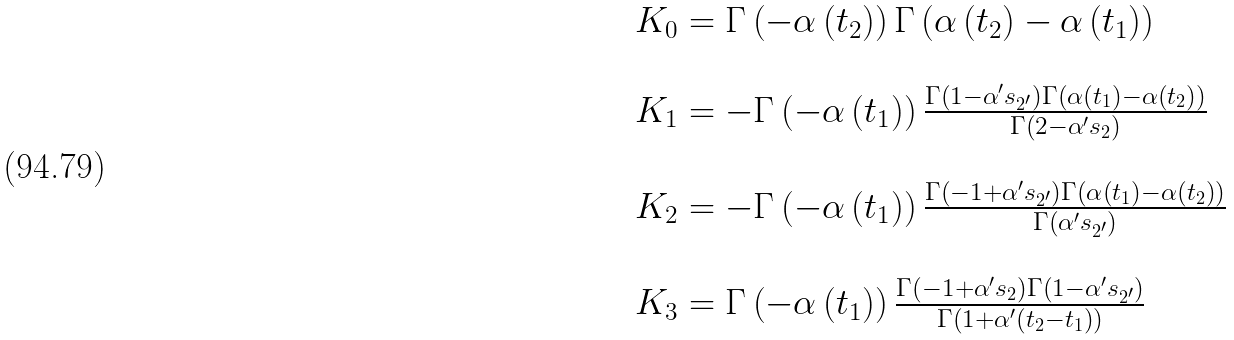<formula> <loc_0><loc_0><loc_500><loc_500>\begin{array} { l } K _ { 0 } = \Gamma \left ( - \alpha \left ( t _ { 2 } \right ) \right ) \Gamma \left ( \alpha \left ( t _ { 2 } \right ) - \alpha \left ( t _ { 1 } \right ) \right ) \\ \\ K _ { 1 } = - \Gamma \left ( - \alpha \left ( t _ { 1 } \right ) \right ) \frac { \Gamma \left ( 1 - \alpha ^ { \prime } s _ { 2 ^ { \prime } } \right ) \Gamma \left ( \alpha \left ( t _ { 1 } \right ) - \alpha \left ( t _ { 2 } \right ) \right ) } { \Gamma \left ( 2 - \alpha ^ { \prime } s _ { 2 } \right ) } \\ \\ K _ { 2 } = - \Gamma \left ( - \alpha \left ( t _ { 1 } \right ) \right ) \frac { \Gamma \left ( - 1 + \alpha ^ { \prime } s _ { 2 ^ { \prime } } \right ) \Gamma \left ( \alpha \left ( t _ { 1 } \right ) - \alpha \left ( t _ { 2 } \right ) \right ) } { \Gamma \left ( \alpha ^ { \prime } s _ { 2 ^ { \prime } } \right ) } \\ \\ K _ { 3 } = \Gamma \left ( - \alpha \left ( t _ { 1 } \right ) \right ) \frac { \Gamma \left ( - 1 + \alpha ^ { \prime } s _ { 2 } \right ) \Gamma \left ( 1 - \alpha ^ { \prime } s _ { 2 ^ { \prime } } \right ) } { \Gamma \left ( 1 + \alpha ^ { \prime } \left ( t _ { 2 } - t _ { 1 } \right ) \right ) } \end{array}</formula> 